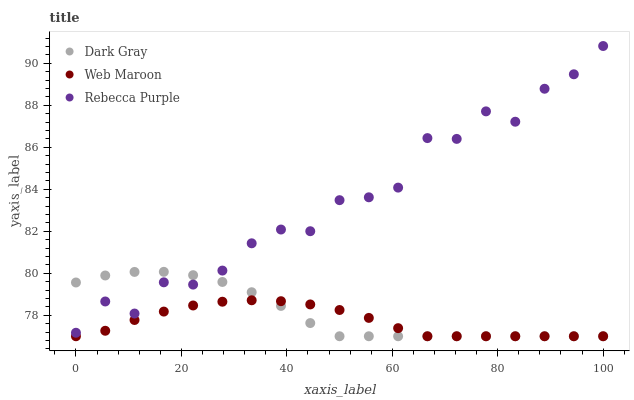Does Web Maroon have the minimum area under the curve?
Answer yes or no. Yes. Does Rebecca Purple have the maximum area under the curve?
Answer yes or no. Yes. Does Rebecca Purple have the minimum area under the curve?
Answer yes or no. No. Does Web Maroon have the maximum area under the curve?
Answer yes or no. No. Is Web Maroon the smoothest?
Answer yes or no. Yes. Is Rebecca Purple the roughest?
Answer yes or no. Yes. Is Rebecca Purple the smoothest?
Answer yes or no. No. Is Web Maroon the roughest?
Answer yes or no. No. Does Dark Gray have the lowest value?
Answer yes or no. Yes. Does Rebecca Purple have the lowest value?
Answer yes or no. No. Does Rebecca Purple have the highest value?
Answer yes or no. Yes. Does Web Maroon have the highest value?
Answer yes or no. No. Is Web Maroon less than Rebecca Purple?
Answer yes or no. Yes. Is Rebecca Purple greater than Web Maroon?
Answer yes or no. Yes. Does Dark Gray intersect Web Maroon?
Answer yes or no. Yes. Is Dark Gray less than Web Maroon?
Answer yes or no. No. Is Dark Gray greater than Web Maroon?
Answer yes or no. No. Does Web Maroon intersect Rebecca Purple?
Answer yes or no. No. 